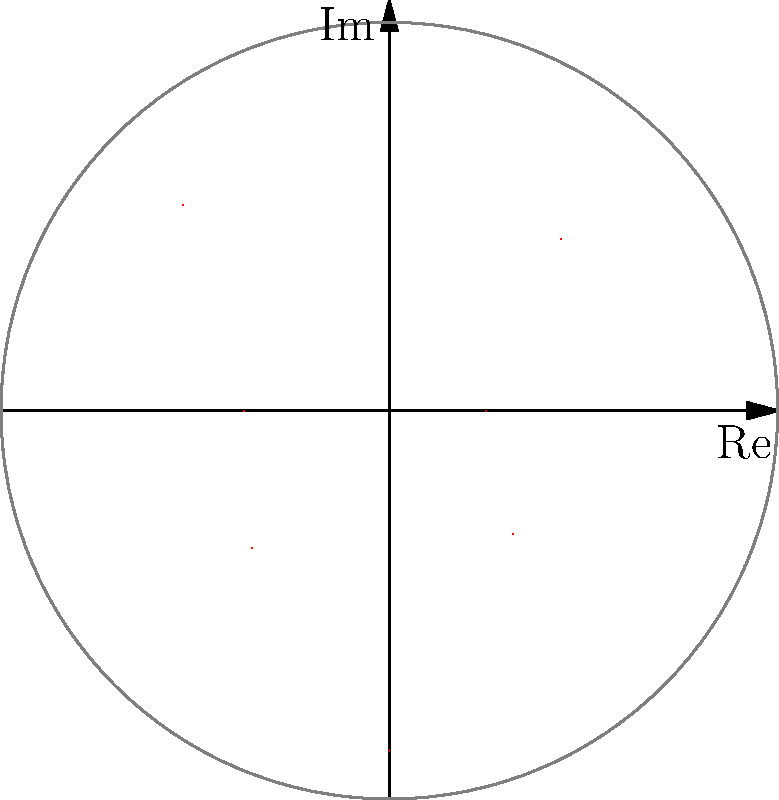You've just posted a TikTok video, and you're tracking its likes over an 8-hour period. The graph shows the number of likes at each hour mark, starting from when you posted it. What's the maximum number of likes your video received during this time, and at which hour mark did it occur? To solve this, let's break it down step-by-step:

1) The graph is a polar plot, where the angle represents time (in hours) and the distance from the center represents the number of likes.

2) The plot is divided into 8 sections, representing 8 hours (a full circle is 24 hours, so each section is 3 hours).

3) We need to identify the point furthest from the center, as this represents the maximum number of likes.

4) Looking at the graph, we can see that the point furthest from the center is at the 3-hour mark (straight up on the graph).

5) To find the number of likes, we need to estimate the distance from the center to this point.

6) The graph has concentric circles, with the outermost representing 400 likes.

7) The point at the 3-hour mark touches this outermost circle.

Therefore, the maximum number of likes (400) occurred at the 3-hour mark after posting.
Answer: 400 likes at 3 hours 